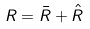Convert formula to latex. <formula><loc_0><loc_0><loc_500><loc_500>R = \bar { R } + \hat { R }</formula> 